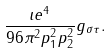Convert formula to latex. <formula><loc_0><loc_0><loc_500><loc_500>\frac { \imath e ^ { 4 } } { 9 6 \pi ^ { 2 } p _ { 1 } ^ { 2 } p _ { 2 } ^ { 2 } } g _ { \sigma \tau } .</formula> 